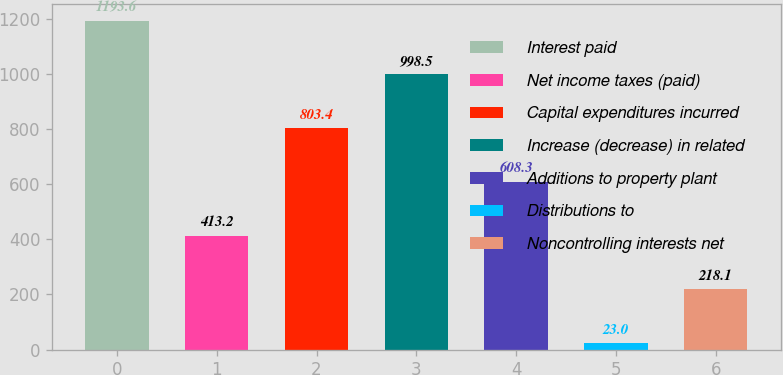Convert chart. <chart><loc_0><loc_0><loc_500><loc_500><bar_chart><fcel>Interest paid<fcel>Net income taxes (paid)<fcel>Capital expenditures incurred<fcel>Increase (decrease) in related<fcel>Additions to property plant<fcel>Distributions to<fcel>Noncontrolling interests net<nl><fcel>1193.6<fcel>413.2<fcel>803.4<fcel>998.5<fcel>608.3<fcel>23<fcel>218.1<nl></chart> 